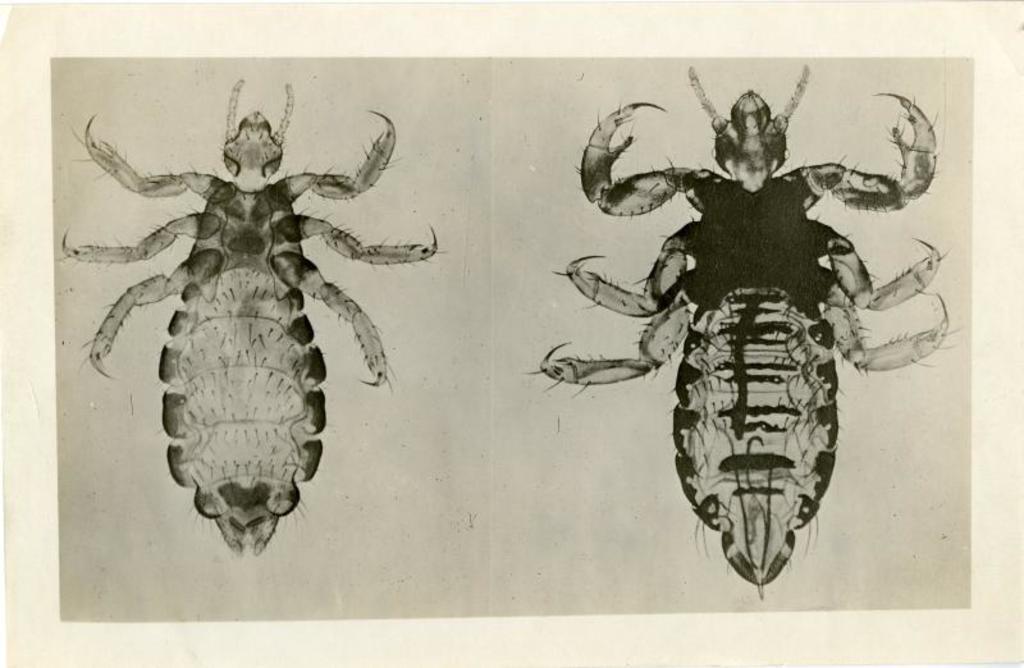Could you give a brief overview of what you see in this image? Here we can see a poster, in the poster we can find images of an insects. 